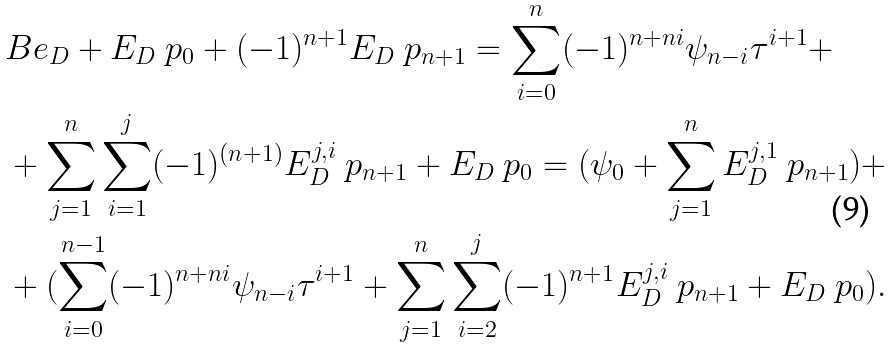Convert formula to latex. <formula><loc_0><loc_0><loc_500><loc_500>& B e _ { D } + E _ { D } \ p _ { 0 } + ( - 1 ) ^ { n + 1 } E _ { D } \ p _ { n + 1 } = \sum _ { i = 0 } ^ { n } ( - 1 ) ^ { n + n i } \psi _ { n - i } \tau ^ { i + 1 } + \\ & + \sum _ { j = 1 } ^ { n } \sum _ { i = 1 } ^ { j } ( - 1 ) ^ { ( n + 1 ) } E _ { D } ^ { j , i } \ p _ { n + 1 } + E _ { D } \ p _ { 0 } = ( \psi _ { 0 } + \sum _ { j = 1 } ^ { n } E _ { D } ^ { j , 1 } \ p _ { n + 1 } ) + \\ & + ( \sum _ { i = 0 } ^ { n - 1 } ( - 1 ) ^ { n + n i } \psi _ { n - i } \tau ^ { i + 1 } + \sum _ { j = 1 } ^ { n } \sum _ { i = 2 } ^ { j } ( - 1 ) ^ { n + 1 } E _ { D } ^ { j , i } \ p _ { n + 1 } + E _ { D } \ p _ { 0 } ) .</formula> 